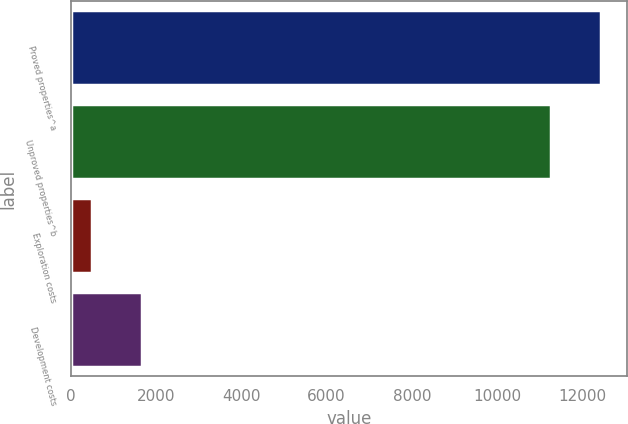Convert chart to OTSL. <chart><loc_0><loc_0><loc_500><loc_500><bar_chart><fcel>Proved properties^a<fcel>Unproved properties^b<fcel>Exploration costs<fcel>Development costs<nl><fcel>12429.3<fcel>11259<fcel>502<fcel>1672.3<nl></chart> 